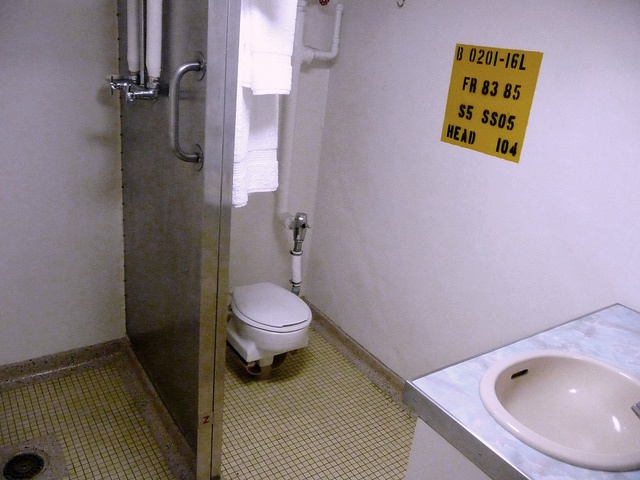Describe the objects in this image and their specific colors. I can see sink in gray, darkgray, and lavender tones and toilet in gray, darkgray, and lavender tones in this image. 